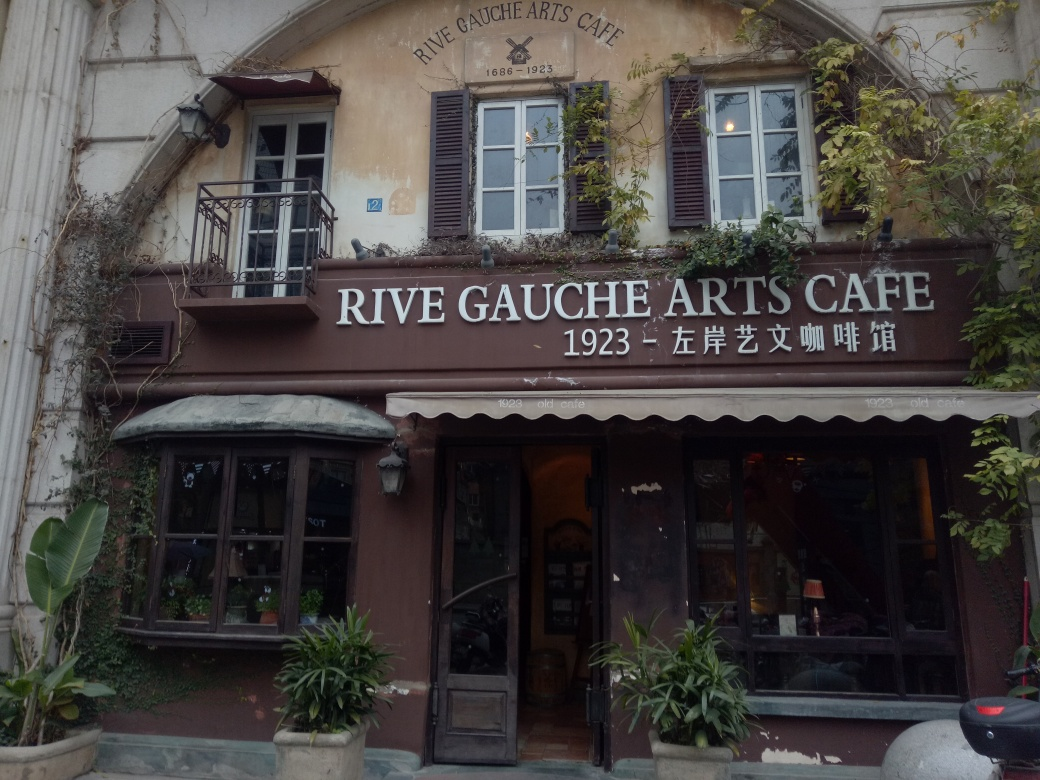What style or era does the architecture of this building represent? The architecture of the building housing the Rive Gauche Arts Café exhibits a quaint, vintage charm that suggests early to mid-20th century influences, coupled with a European flair that is amplified by the shop's façade and typographic design. 